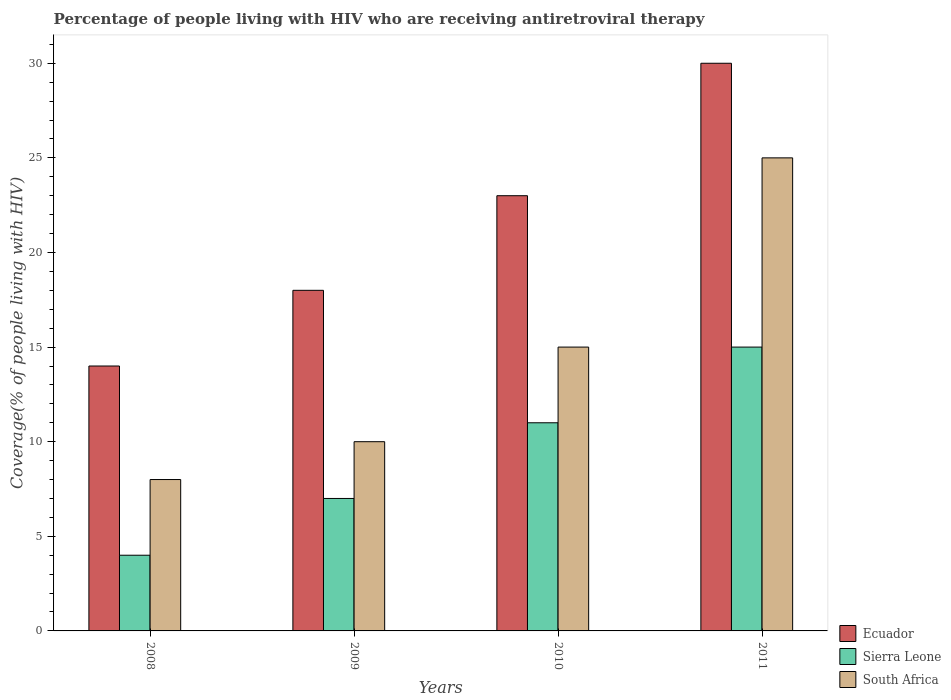How many different coloured bars are there?
Give a very brief answer. 3. How many bars are there on the 4th tick from the left?
Give a very brief answer. 3. How many bars are there on the 1st tick from the right?
Provide a short and direct response. 3. What is the percentage of the HIV infected people who are receiving antiretroviral therapy in Ecuador in 2009?
Your answer should be very brief. 18. Across all years, what is the maximum percentage of the HIV infected people who are receiving antiretroviral therapy in Ecuador?
Offer a terse response. 30. Across all years, what is the minimum percentage of the HIV infected people who are receiving antiretroviral therapy in Ecuador?
Ensure brevity in your answer.  14. In which year was the percentage of the HIV infected people who are receiving antiretroviral therapy in South Africa maximum?
Keep it short and to the point. 2011. What is the total percentage of the HIV infected people who are receiving antiretroviral therapy in Sierra Leone in the graph?
Offer a very short reply. 37. What is the difference between the percentage of the HIV infected people who are receiving antiretroviral therapy in Ecuador in 2008 and that in 2011?
Offer a terse response. -16. What is the difference between the percentage of the HIV infected people who are receiving antiretroviral therapy in Ecuador in 2011 and the percentage of the HIV infected people who are receiving antiretroviral therapy in South Africa in 2009?
Ensure brevity in your answer.  20. What is the average percentage of the HIV infected people who are receiving antiretroviral therapy in Sierra Leone per year?
Offer a very short reply. 9.25. In the year 2010, what is the difference between the percentage of the HIV infected people who are receiving antiretroviral therapy in South Africa and percentage of the HIV infected people who are receiving antiretroviral therapy in Ecuador?
Keep it short and to the point. -8. What is the ratio of the percentage of the HIV infected people who are receiving antiretroviral therapy in Ecuador in 2010 to that in 2011?
Make the answer very short. 0.77. Is the difference between the percentage of the HIV infected people who are receiving antiretroviral therapy in South Africa in 2008 and 2011 greater than the difference between the percentage of the HIV infected people who are receiving antiretroviral therapy in Ecuador in 2008 and 2011?
Your answer should be compact. No. What is the difference between the highest and the second highest percentage of the HIV infected people who are receiving antiretroviral therapy in Ecuador?
Your response must be concise. 7. What is the difference between the highest and the lowest percentage of the HIV infected people who are receiving antiretroviral therapy in Sierra Leone?
Offer a terse response. 11. In how many years, is the percentage of the HIV infected people who are receiving antiretroviral therapy in Ecuador greater than the average percentage of the HIV infected people who are receiving antiretroviral therapy in Ecuador taken over all years?
Provide a short and direct response. 2. Is the sum of the percentage of the HIV infected people who are receiving antiretroviral therapy in Ecuador in 2010 and 2011 greater than the maximum percentage of the HIV infected people who are receiving antiretroviral therapy in South Africa across all years?
Offer a very short reply. Yes. What does the 2nd bar from the left in 2009 represents?
Offer a very short reply. Sierra Leone. What does the 1st bar from the right in 2009 represents?
Ensure brevity in your answer.  South Africa. Is it the case that in every year, the sum of the percentage of the HIV infected people who are receiving antiretroviral therapy in Sierra Leone and percentage of the HIV infected people who are receiving antiretroviral therapy in South Africa is greater than the percentage of the HIV infected people who are receiving antiretroviral therapy in Ecuador?
Ensure brevity in your answer.  No. Does the graph contain any zero values?
Provide a short and direct response. No. Does the graph contain grids?
Your response must be concise. No. What is the title of the graph?
Keep it short and to the point. Percentage of people living with HIV who are receiving antiretroviral therapy. What is the label or title of the X-axis?
Keep it short and to the point. Years. What is the label or title of the Y-axis?
Provide a succinct answer. Coverage(% of people living with HIV). What is the Coverage(% of people living with HIV) of Ecuador in 2008?
Provide a succinct answer. 14. What is the Coverage(% of people living with HIV) of Sierra Leone in 2008?
Make the answer very short. 4. What is the Coverage(% of people living with HIV) of Sierra Leone in 2009?
Give a very brief answer. 7. What is the Coverage(% of people living with HIV) in South Africa in 2009?
Your answer should be compact. 10. What is the Coverage(% of people living with HIV) in South Africa in 2010?
Offer a terse response. 15. Across all years, what is the maximum Coverage(% of people living with HIV) of Ecuador?
Offer a very short reply. 30. Across all years, what is the maximum Coverage(% of people living with HIV) of Sierra Leone?
Your answer should be compact. 15. Across all years, what is the maximum Coverage(% of people living with HIV) in South Africa?
Ensure brevity in your answer.  25. Across all years, what is the minimum Coverage(% of people living with HIV) in Ecuador?
Your answer should be very brief. 14. Across all years, what is the minimum Coverage(% of people living with HIV) of South Africa?
Offer a very short reply. 8. What is the total Coverage(% of people living with HIV) of Ecuador in the graph?
Provide a short and direct response. 85. What is the total Coverage(% of people living with HIV) of Sierra Leone in the graph?
Offer a very short reply. 37. What is the total Coverage(% of people living with HIV) of South Africa in the graph?
Your answer should be compact. 58. What is the difference between the Coverage(% of people living with HIV) in Ecuador in 2008 and that in 2010?
Keep it short and to the point. -9. What is the difference between the Coverage(% of people living with HIV) of Sierra Leone in 2008 and that in 2010?
Offer a very short reply. -7. What is the difference between the Coverage(% of people living with HIV) in South Africa in 2008 and that in 2010?
Offer a terse response. -7. What is the difference between the Coverage(% of people living with HIV) in South Africa in 2009 and that in 2010?
Offer a very short reply. -5. What is the difference between the Coverage(% of people living with HIV) in Ecuador in 2009 and that in 2011?
Offer a terse response. -12. What is the difference between the Coverage(% of people living with HIV) in Sierra Leone in 2009 and that in 2011?
Your answer should be very brief. -8. What is the difference between the Coverage(% of people living with HIV) of Sierra Leone in 2010 and that in 2011?
Keep it short and to the point. -4. What is the difference between the Coverage(% of people living with HIV) of South Africa in 2010 and that in 2011?
Your answer should be compact. -10. What is the difference between the Coverage(% of people living with HIV) of Ecuador in 2008 and the Coverage(% of people living with HIV) of South Africa in 2009?
Your answer should be compact. 4. What is the difference between the Coverage(% of people living with HIV) of Sierra Leone in 2008 and the Coverage(% of people living with HIV) of South Africa in 2009?
Your answer should be compact. -6. What is the difference between the Coverage(% of people living with HIV) of Ecuador in 2008 and the Coverage(% of people living with HIV) of Sierra Leone in 2010?
Ensure brevity in your answer.  3. What is the difference between the Coverage(% of people living with HIV) of Ecuador in 2008 and the Coverage(% of people living with HIV) of South Africa in 2010?
Provide a succinct answer. -1. What is the difference between the Coverage(% of people living with HIV) in Sierra Leone in 2008 and the Coverage(% of people living with HIV) in South Africa in 2010?
Provide a short and direct response. -11. What is the difference between the Coverage(% of people living with HIV) in Ecuador in 2008 and the Coverage(% of people living with HIV) in South Africa in 2011?
Your answer should be very brief. -11. What is the difference between the Coverage(% of people living with HIV) of Ecuador in 2009 and the Coverage(% of people living with HIV) of South Africa in 2010?
Offer a terse response. 3. What is the difference between the Coverage(% of people living with HIV) of Sierra Leone in 2009 and the Coverage(% of people living with HIV) of South Africa in 2010?
Provide a short and direct response. -8. What is the difference between the Coverage(% of people living with HIV) of Ecuador in 2010 and the Coverage(% of people living with HIV) of Sierra Leone in 2011?
Provide a succinct answer. 8. What is the difference between the Coverage(% of people living with HIV) of Sierra Leone in 2010 and the Coverage(% of people living with HIV) of South Africa in 2011?
Give a very brief answer. -14. What is the average Coverage(% of people living with HIV) in Ecuador per year?
Your answer should be compact. 21.25. What is the average Coverage(% of people living with HIV) of Sierra Leone per year?
Make the answer very short. 9.25. In the year 2008, what is the difference between the Coverage(% of people living with HIV) of Ecuador and Coverage(% of people living with HIV) of Sierra Leone?
Ensure brevity in your answer.  10. In the year 2009, what is the difference between the Coverage(% of people living with HIV) of Ecuador and Coverage(% of people living with HIV) of Sierra Leone?
Make the answer very short. 11. In the year 2009, what is the difference between the Coverage(% of people living with HIV) of Ecuador and Coverage(% of people living with HIV) of South Africa?
Ensure brevity in your answer.  8. In the year 2010, what is the difference between the Coverage(% of people living with HIV) in Ecuador and Coverage(% of people living with HIV) in Sierra Leone?
Keep it short and to the point. 12. In the year 2010, what is the difference between the Coverage(% of people living with HIV) of Sierra Leone and Coverage(% of people living with HIV) of South Africa?
Your answer should be very brief. -4. In the year 2011, what is the difference between the Coverage(% of people living with HIV) in Ecuador and Coverage(% of people living with HIV) in South Africa?
Provide a succinct answer. 5. In the year 2011, what is the difference between the Coverage(% of people living with HIV) of Sierra Leone and Coverage(% of people living with HIV) of South Africa?
Your response must be concise. -10. What is the ratio of the Coverage(% of people living with HIV) in Ecuador in 2008 to that in 2009?
Give a very brief answer. 0.78. What is the ratio of the Coverage(% of people living with HIV) in Sierra Leone in 2008 to that in 2009?
Offer a terse response. 0.57. What is the ratio of the Coverage(% of people living with HIV) of South Africa in 2008 to that in 2009?
Make the answer very short. 0.8. What is the ratio of the Coverage(% of people living with HIV) in Ecuador in 2008 to that in 2010?
Offer a terse response. 0.61. What is the ratio of the Coverage(% of people living with HIV) in Sierra Leone in 2008 to that in 2010?
Give a very brief answer. 0.36. What is the ratio of the Coverage(% of people living with HIV) of South Africa in 2008 to that in 2010?
Keep it short and to the point. 0.53. What is the ratio of the Coverage(% of people living with HIV) in Ecuador in 2008 to that in 2011?
Offer a very short reply. 0.47. What is the ratio of the Coverage(% of people living with HIV) in Sierra Leone in 2008 to that in 2011?
Ensure brevity in your answer.  0.27. What is the ratio of the Coverage(% of people living with HIV) in South Africa in 2008 to that in 2011?
Offer a very short reply. 0.32. What is the ratio of the Coverage(% of people living with HIV) in Ecuador in 2009 to that in 2010?
Your answer should be very brief. 0.78. What is the ratio of the Coverage(% of people living with HIV) in Sierra Leone in 2009 to that in 2010?
Your response must be concise. 0.64. What is the ratio of the Coverage(% of people living with HIV) of Sierra Leone in 2009 to that in 2011?
Ensure brevity in your answer.  0.47. What is the ratio of the Coverage(% of people living with HIV) in South Africa in 2009 to that in 2011?
Offer a terse response. 0.4. What is the ratio of the Coverage(% of people living with HIV) in Ecuador in 2010 to that in 2011?
Ensure brevity in your answer.  0.77. What is the ratio of the Coverage(% of people living with HIV) of Sierra Leone in 2010 to that in 2011?
Offer a terse response. 0.73. What is the ratio of the Coverage(% of people living with HIV) in South Africa in 2010 to that in 2011?
Your answer should be very brief. 0.6. What is the difference between the highest and the second highest Coverage(% of people living with HIV) of Ecuador?
Provide a succinct answer. 7. What is the difference between the highest and the second highest Coverage(% of people living with HIV) of Sierra Leone?
Offer a very short reply. 4. What is the difference between the highest and the second highest Coverage(% of people living with HIV) in South Africa?
Offer a terse response. 10. What is the difference between the highest and the lowest Coverage(% of people living with HIV) of South Africa?
Your answer should be very brief. 17. 